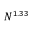<formula> <loc_0><loc_0><loc_500><loc_500>N ^ { 1 . 3 3 }</formula> 